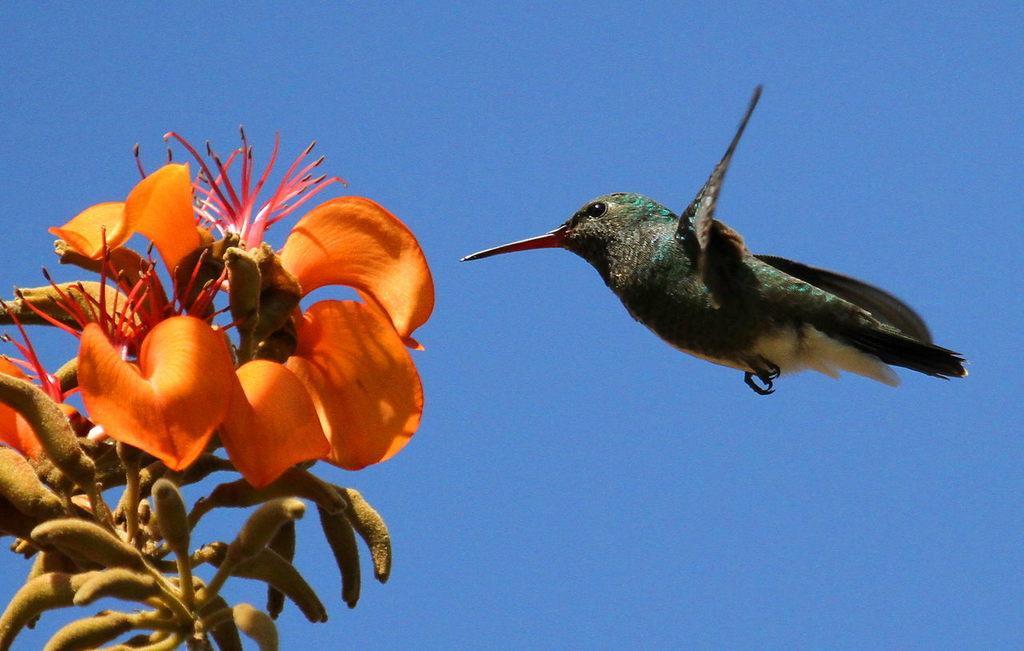Could you give a brief overview of what you see in this image? This picture is clicked outside. On the right we can see a bird flying in the air. On the left we can see the flowers and some other items. In the background we can see the sky. 